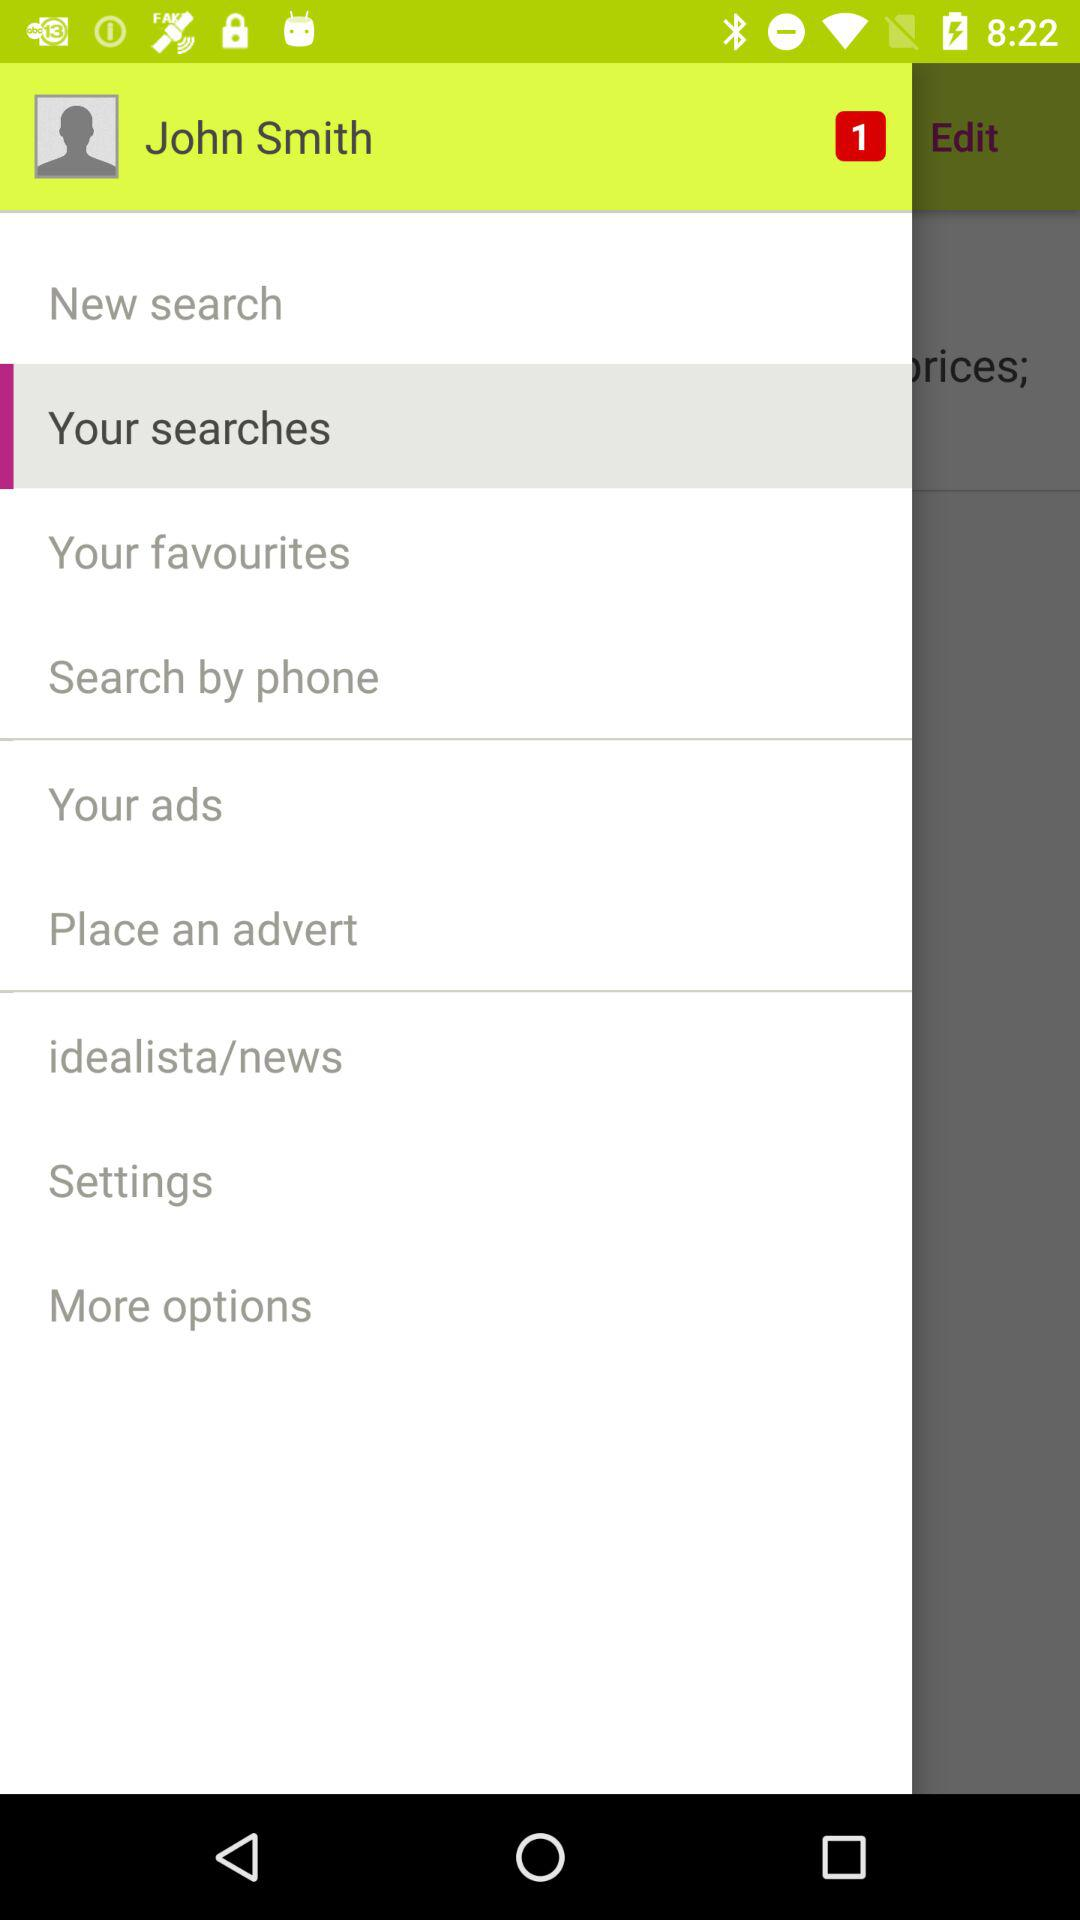How many notifications are there? There is 1 notification. 